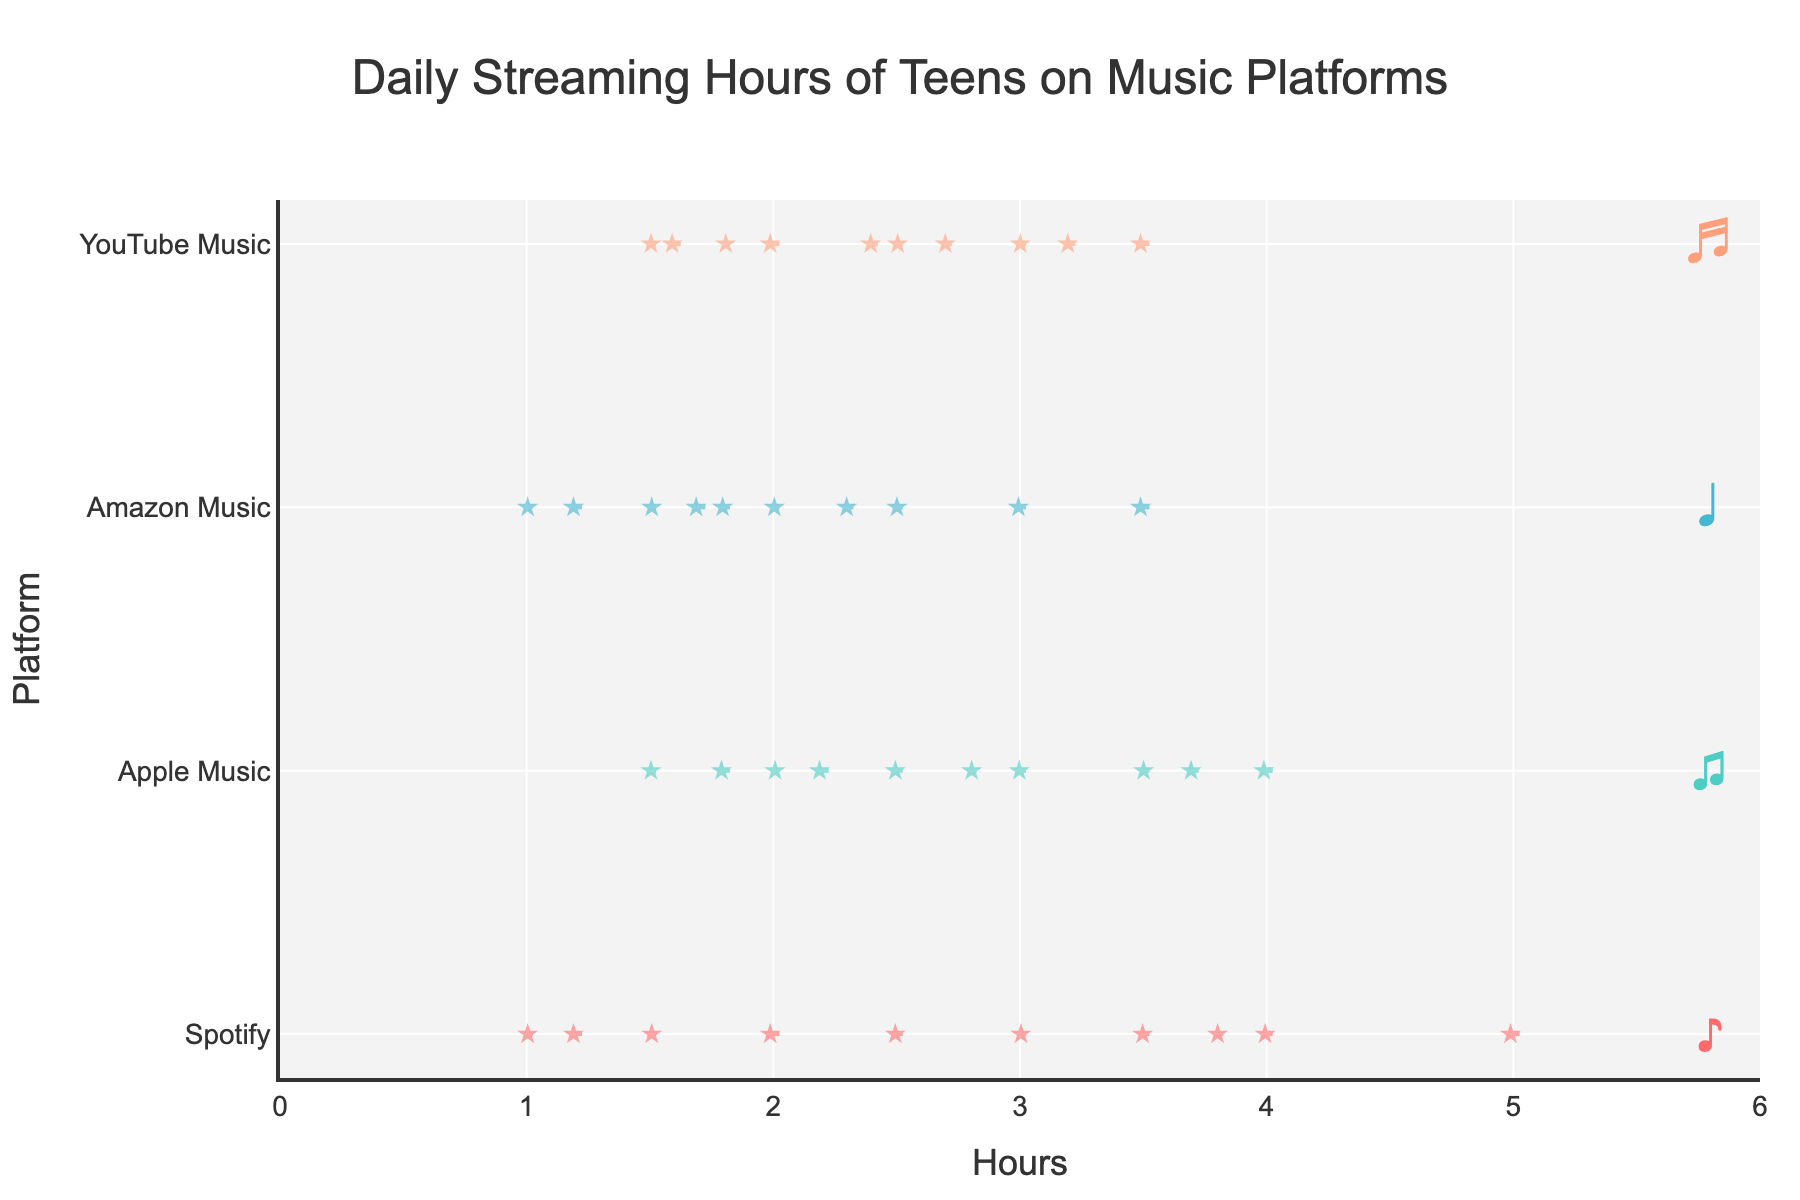what is the title of this figure? The title of the figure is located at the top center of the chart. This is usually the most prominent and largest text in the figure.
Answer: Daily Streaming Hours of Teens on Music Platforms What is represented on the x-axis of the chart? The x-axis typically includes a label, and in this figure, it is the horizontal axis. The text near the axis indicates what it represents.
Answer: Hours Which music platform shows the greatest range in streaming hours? Look for the platform with the widest spread (from minimum to maximum) in the violin plots. The range is the difference between the longest and shortest horizontal extents.
Answer: Spotify Which platform has the highest average streaming hours? Identify the mean lines (often slightly thicker horizontal lines) within the violin plots for each platform. Compare their positions to find the highest.
Answer: Spotify All platforms seem to have boxes in their plots. What do these boxes indicate? In a violin plot, boxes often represent the interquartile range (IQR), which shows where the middle 50% of the data is concentrated. These boxes are usually located in the center of the violins.
Answer: Interquartile Range (IQR) Which platform's users have the most consistent streaming hours? Consistency can be determined by the narrowest spread. Identify the platform with the narrowest violin plot, indicating less variation in hours streamed.
Answer: Amazon Music How many data points are there for YouTube Music? Count the number of star markers within the YouTube Music violin plot. These stars represent individual data points.
Answer: 10 What's the median streaming hours for Apple Music? Locate the box within the Apple Music violin and identify the line in the middle of the box. This line represents the median.
Answer: Approximately 2.85 hours Between Spotify and YouTube Music, which has a higher median streaming hour? Compare the median lines of the Spotify and YouTube Music violin plots to see which is higher.
Answer: Spotify Which platform shows more variability in streaming hours, Amazon Music or Apple Music? Evaluate the width and spread of the violin plots for both platforms. The wider and more spread-out plot indicates higher variability.
Answer: Apple Music 